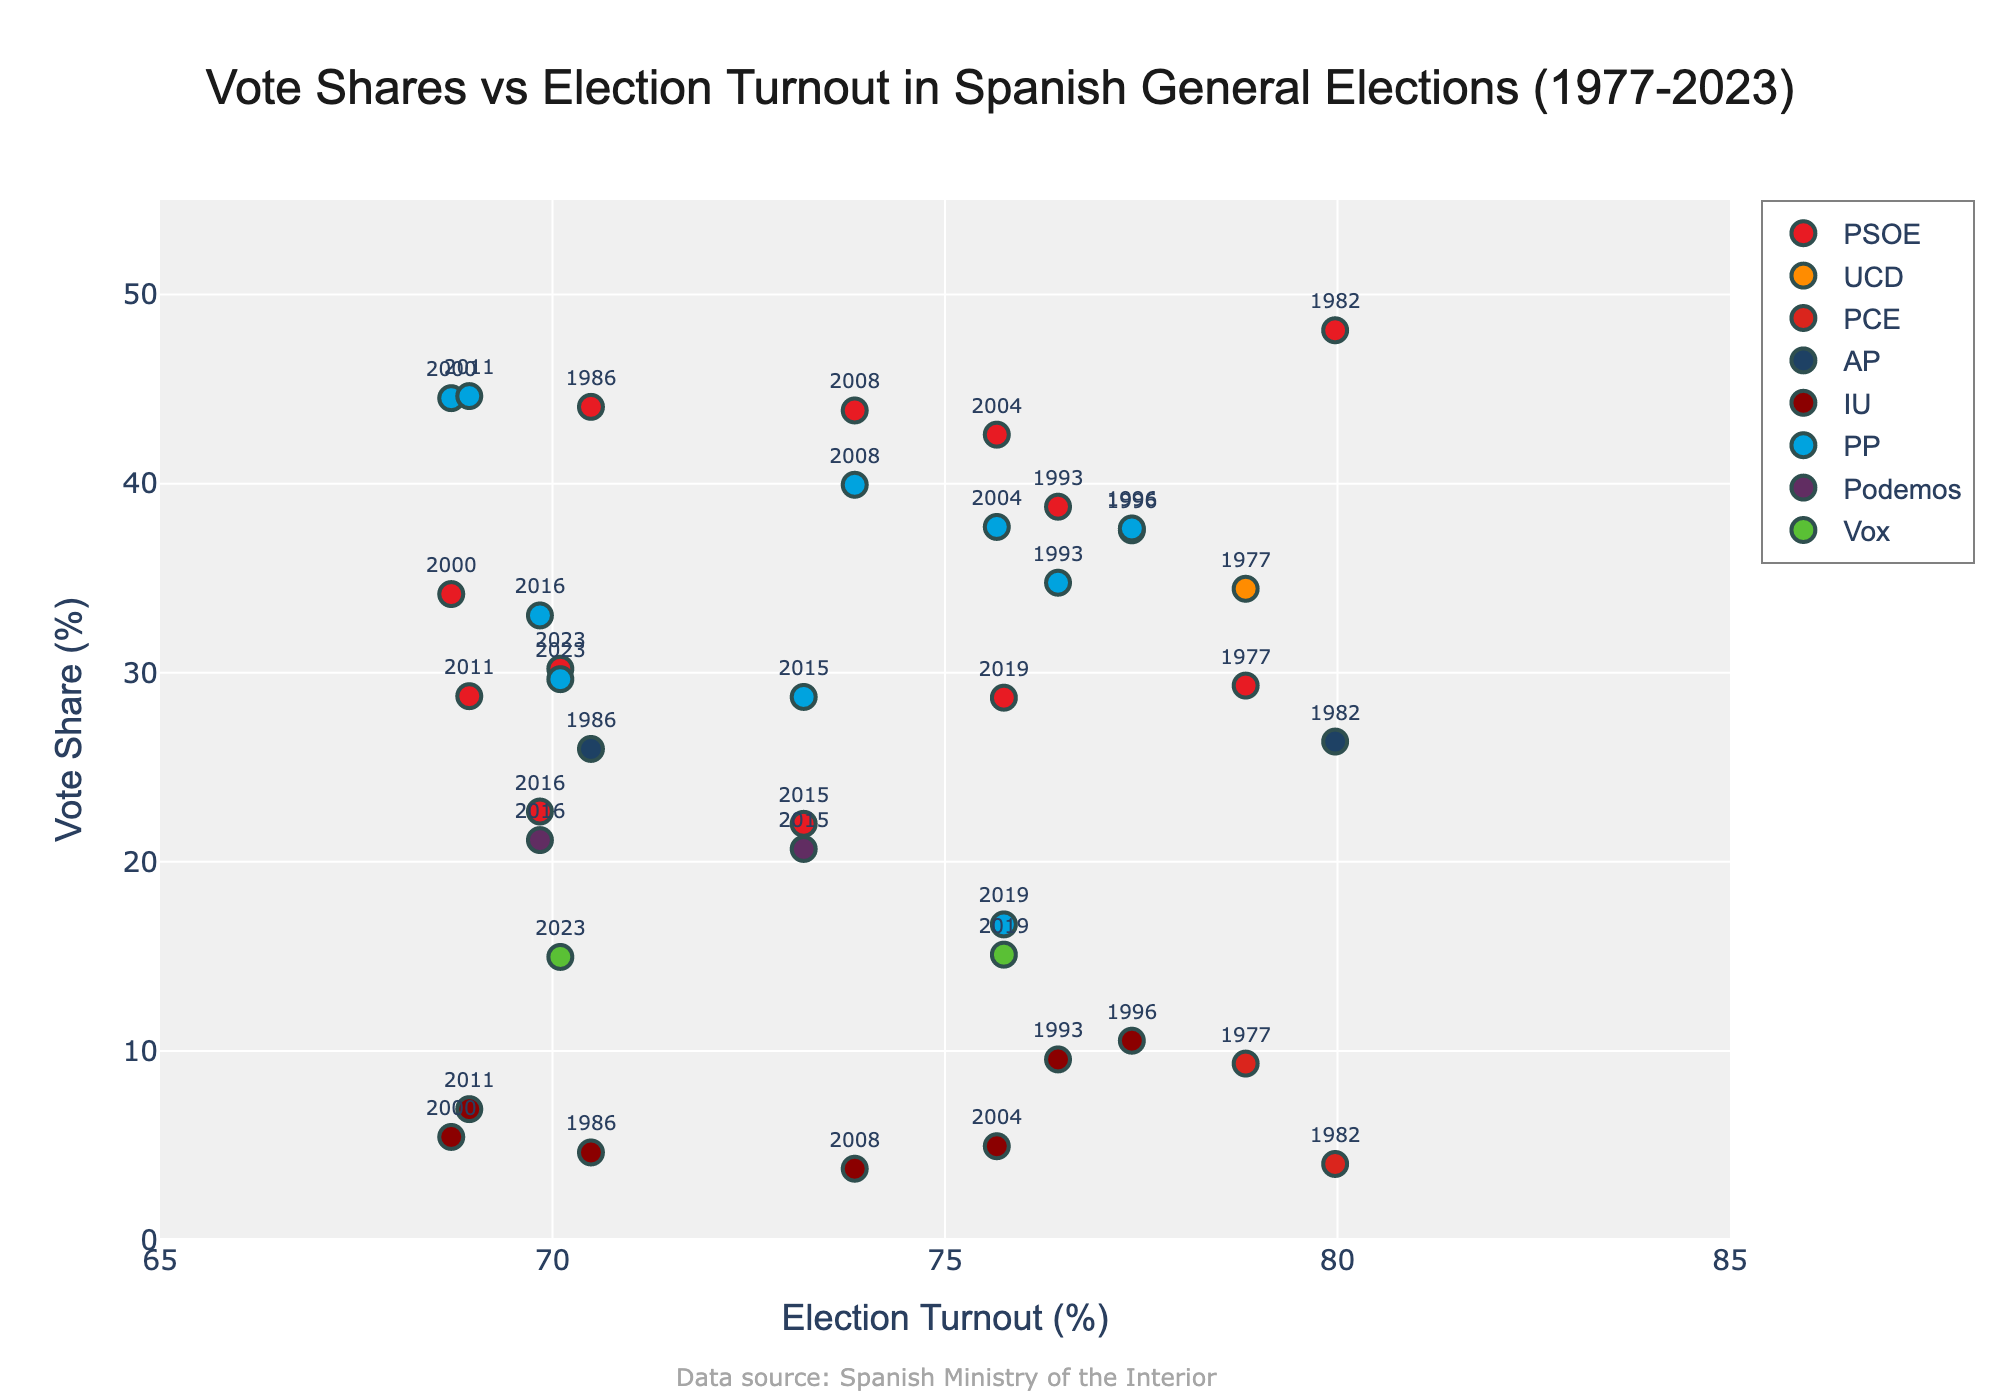What is the title of the figure? The title is written at the top of the figure in bold font. It reads, "Vote Shares vs Election Turnout in Spanish General Elections (1977-2023)."
Answer: Vote Shares vs Election Turnout in Spanish General Elections (1977-2023) What are the x-axis and y-axis labels? The labels for the axes can be seen along the edge of the x-axis and y-axis. The x-axis is labeled "Election Turnout (%)" and the y-axis is labeled "Vote Share (%)."
Answer: Election Turnout (%) and Vote Share (%) Which political party appears to have the highest vote share in the data? By observing the position of the markers on the y-axis, the highest vote share is slightly above 48%. The year 1982 is labeled next to the PSOE marker, which confirms the peak vote share.
Answer: PSOE What is the highest vote share reached by the PP (Partido Popular)? Locate the PP markers and check their highest y-axis position. The PP marker around y=44.63 in year 2011 indicates the peak vote share.
Answer: 44.63% How did the vote share of PSOE change from 1977 to 1982? Locate the PSOE markers for 1977 and 1982. The vote share increased from around 29.32% (1977) to 48.11% (1982).
Answer: It increased from 29.32% to 48.11% Which year had the highest voter turnout, and what was it? The highest voter turnout is indicated by the farthest right marker on the x-axis. The markers for the year 1982 have a turnout of 79.97%.
Answer: 1982, 79.97% Compare the vote shares of PSOE and PP in 2019. Which party had the higher vote share? Locate the 2019 markers for both parties. PSOE has a marker at around 28.68%, while PP has one at around 16.69%.
Answer: PSOE had the higher vote share In which years did PP surpass PSOE in vote share? Examine the markers for PPO and PSOE, and note the years when PP's marker is above PSOE's marker. PP overtakes PSOE in 1996, 2000, and 2011.
Answer: 1996, 2000, 2011 What trend can be observed in voter turnout between 2000 and 2004? Compare the x-axis positions of the markers from 2000 and 2004. The turnout increased from around 68.71% (2000) to 75.66% (2004).
Answer: Turnout increased Which parties were present in the 2015 and 2016 elections that were not there in earlier years? Identify the markers in 2015 and 2016 and see if any new names appear. Podemos appears in these years but not in earlier ones.
Answer: Podemos 